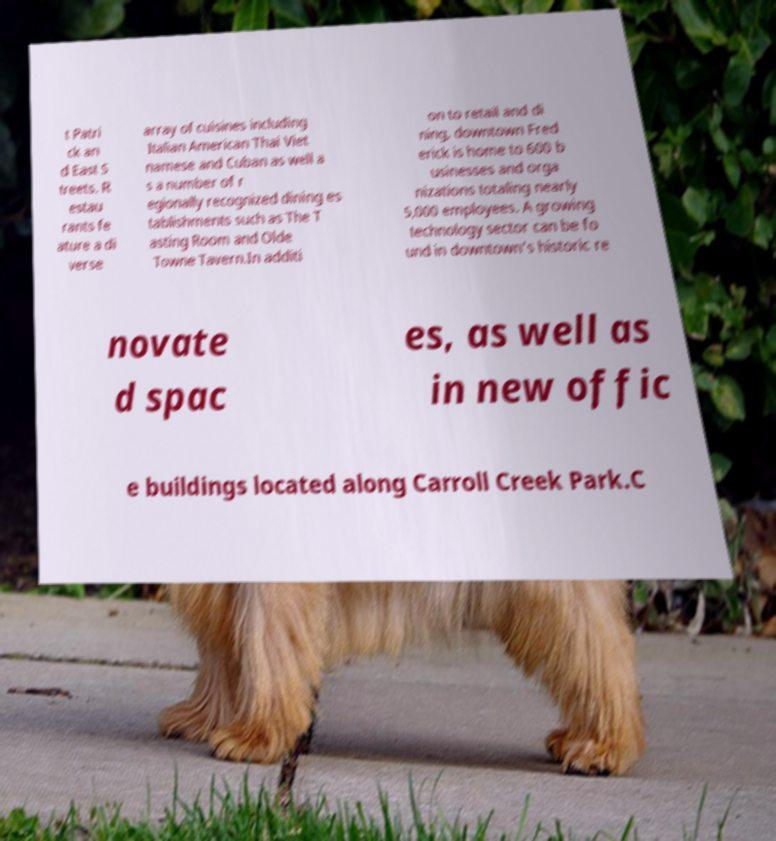For documentation purposes, I need the text within this image transcribed. Could you provide that? t Patri ck an d East S treets. R estau rants fe ature a di verse array of cuisines including Italian American Thai Viet namese and Cuban as well a s a number of r egionally recognized dining es tablishments such as The T asting Room and Olde Towne Tavern.In additi on to retail and di ning, downtown Fred erick is home to 600 b usinesses and orga nizations totaling nearly 5,000 employees. A growing technology sector can be fo und in downtown's historic re novate d spac es, as well as in new offic e buildings located along Carroll Creek Park.C 